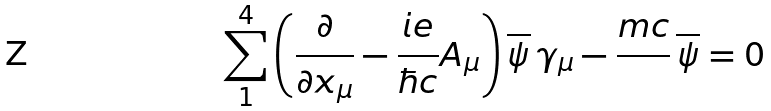<formula> <loc_0><loc_0><loc_500><loc_500>\sum _ { 1 } ^ { 4 } \left ( \frac { \partial } { \partial x _ { \mu } } - \frac { i e } { \hbar { c } } A _ { \mu } \right ) \overline { \psi } \, \gamma _ { \mu } - \frac { m c } { } \, \overline { \psi } = 0</formula> 